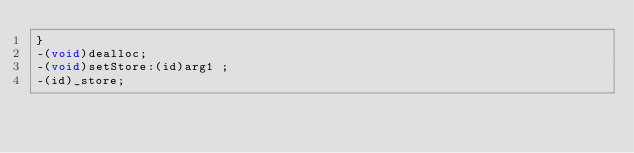<code> <loc_0><loc_0><loc_500><loc_500><_C_>}
-(void)dealloc;
-(void)setStore:(id)arg1 ;
-(id)_store;</code> 